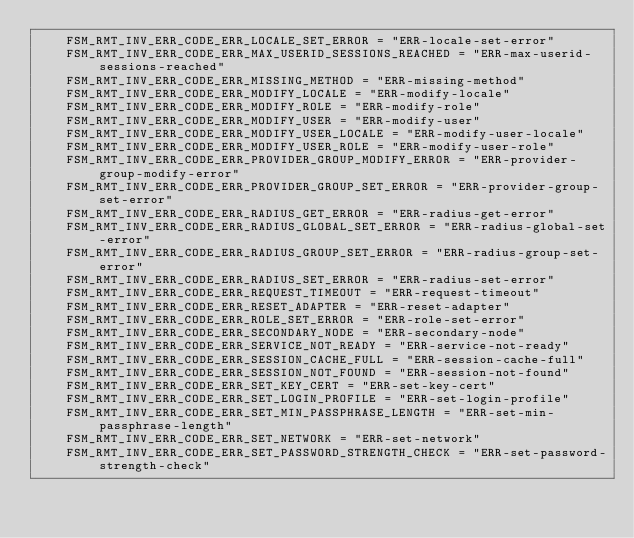Convert code to text. <code><loc_0><loc_0><loc_500><loc_500><_Python_>    FSM_RMT_INV_ERR_CODE_ERR_LOCALE_SET_ERROR = "ERR-locale-set-error"
    FSM_RMT_INV_ERR_CODE_ERR_MAX_USERID_SESSIONS_REACHED = "ERR-max-userid-sessions-reached"
    FSM_RMT_INV_ERR_CODE_ERR_MISSING_METHOD = "ERR-missing-method"
    FSM_RMT_INV_ERR_CODE_ERR_MODIFY_LOCALE = "ERR-modify-locale"
    FSM_RMT_INV_ERR_CODE_ERR_MODIFY_ROLE = "ERR-modify-role"
    FSM_RMT_INV_ERR_CODE_ERR_MODIFY_USER = "ERR-modify-user"
    FSM_RMT_INV_ERR_CODE_ERR_MODIFY_USER_LOCALE = "ERR-modify-user-locale"
    FSM_RMT_INV_ERR_CODE_ERR_MODIFY_USER_ROLE = "ERR-modify-user-role"
    FSM_RMT_INV_ERR_CODE_ERR_PROVIDER_GROUP_MODIFY_ERROR = "ERR-provider-group-modify-error"
    FSM_RMT_INV_ERR_CODE_ERR_PROVIDER_GROUP_SET_ERROR = "ERR-provider-group-set-error"
    FSM_RMT_INV_ERR_CODE_ERR_RADIUS_GET_ERROR = "ERR-radius-get-error"
    FSM_RMT_INV_ERR_CODE_ERR_RADIUS_GLOBAL_SET_ERROR = "ERR-radius-global-set-error"
    FSM_RMT_INV_ERR_CODE_ERR_RADIUS_GROUP_SET_ERROR = "ERR-radius-group-set-error"
    FSM_RMT_INV_ERR_CODE_ERR_RADIUS_SET_ERROR = "ERR-radius-set-error"
    FSM_RMT_INV_ERR_CODE_ERR_REQUEST_TIMEOUT = "ERR-request-timeout"
    FSM_RMT_INV_ERR_CODE_ERR_RESET_ADAPTER = "ERR-reset-adapter"
    FSM_RMT_INV_ERR_CODE_ERR_ROLE_SET_ERROR = "ERR-role-set-error"
    FSM_RMT_INV_ERR_CODE_ERR_SECONDARY_NODE = "ERR-secondary-node"
    FSM_RMT_INV_ERR_CODE_ERR_SERVICE_NOT_READY = "ERR-service-not-ready"
    FSM_RMT_INV_ERR_CODE_ERR_SESSION_CACHE_FULL = "ERR-session-cache-full"
    FSM_RMT_INV_ERR_CODE_ERR_SESSION_NOT_FOUND = "ERR-session-not-found"
    FSM_RMT_INV_ERR_CODE_ERR_SET_KEY_CERT = "ERR-set-key-cert"
    FSM_RMT_INV_ERR_CODE_ERR_SET_LOGIN_PROFILE = "ERR-set-login-profile"
    FSM_RMT_INV_ERR_CODE_ERR_SET_MIN_PASSPHRASE_LENGTH = "ERR-set-min-passphrase-length"
    FSM_RMT_INV_ERR_CODE_ERR_SET_NETWORK = "ERR-set-network"
    FSM_RMT_INV_ERR_CODE_ERR_SET_PASSWORD_STRENGTH_CHECK = "ERR-set-password-strength-check"</code> 